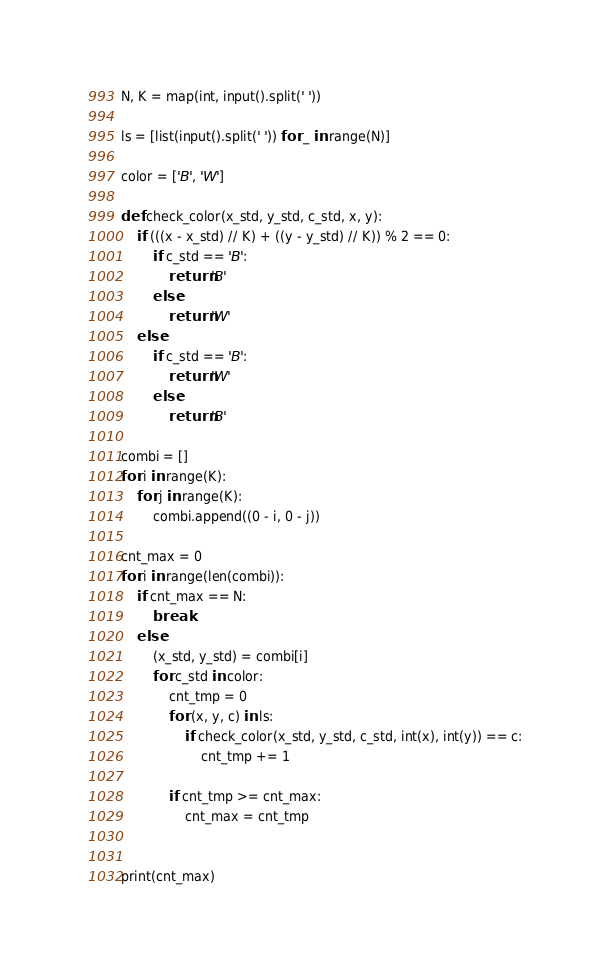Convert code to text. <code><loc_0><loc_0><loc_500><loc_500><_Python_>N, K = map(int, input().split(' '))

ls = [list(input().split(' ')) for _ in range(N)]

color = ['B', 'W'] 

def check_color(x_std, y_std, c_std, x, y):
    if (((x - x_std) // K) + ((y - y_std) // K)) % 2 == 0:
        if c_std == 'B':
            return 'B'
        else:
            return 'W'
    else:
        if c_std == 'B':
            return 'W'
        else:
            return 'B'     

combi = []
for i in range(K):
    for j in range(K):
        combi.append((0 - i, 0 - j))        

cnt_max = 0
for i in range(len(combi)):
    if cnt_max == N:
        break
    else:
        (x_std, y_std) = combi[i]
        for c_std in color:
            cnt_tmp = 0
            for (x, y, c) in ls:
                if check_color(x_std, y_std, c_std, int(x), int(y)) == c:
                    cnt_tmp += 1

            if cnt_tmp >= cnt_max:
                cnt_max = cnt_tmp
                    
        
print(cnt_max)</code> 